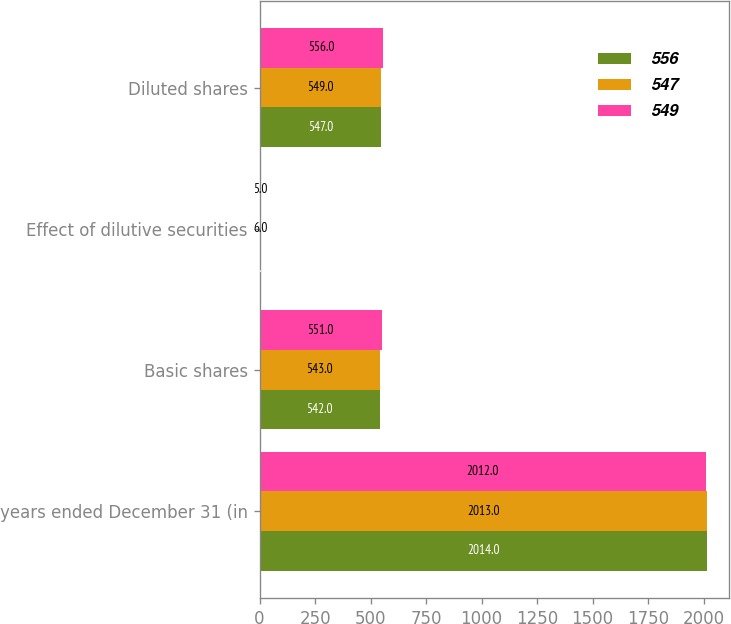<chart> <loc_0><loc_0><loc_500><loc_500><stacked_bar_chart><ecel><fcel>years ended December 31 (in<fcel>Basic shares<fcel>Effect of dilutive securities<fcel>Diluted shares<nl><fcel>556<fcel>2014<fcel>542<fcel>5<fcel>547<nl><fcel>547<fcel>2013<fcel>543<fcel>6<fcel>549<nl><fcel>549<fcel>2012<fcel>551<fcel>5<fcel>556<nl></chart> 